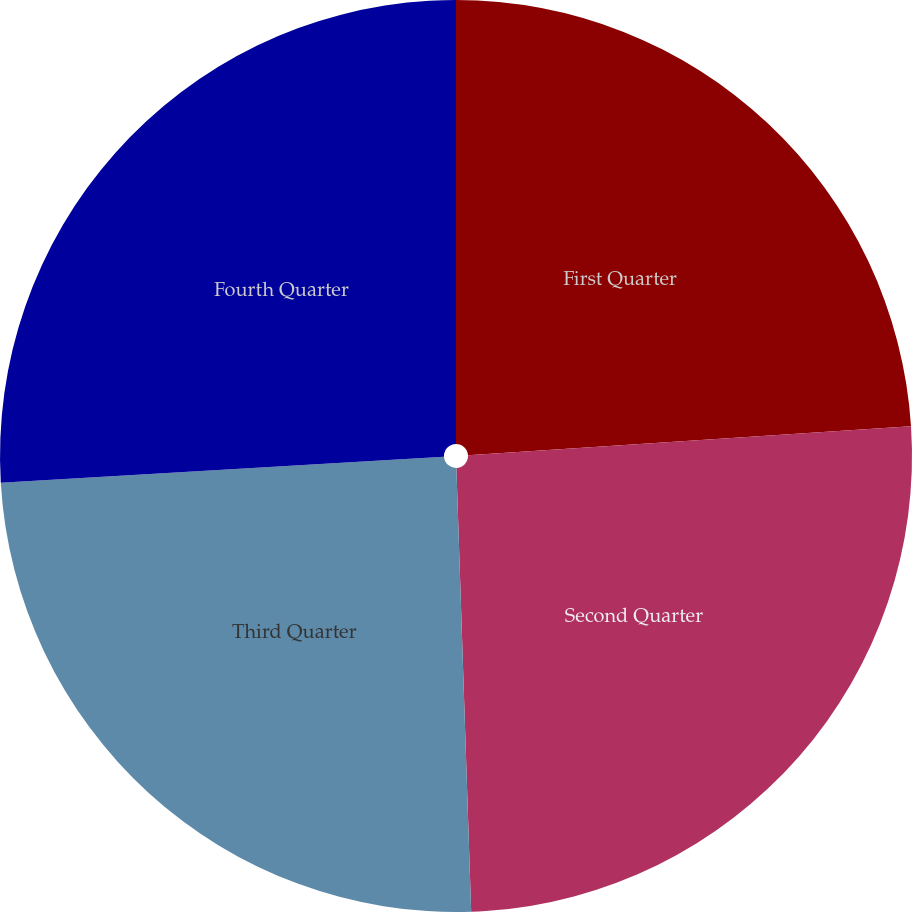<chart> <loc_0><loc_0><loc_500><loc_500><pie_chart><fcel>First Quarter<fcel>Second Quarter<fcel>Third Quarter<fcel>Fourth Quarter<nl><fcel>23.96%<fcel>25.51%<fcel>24.6%<fcel>25.93%<nl></chart> 